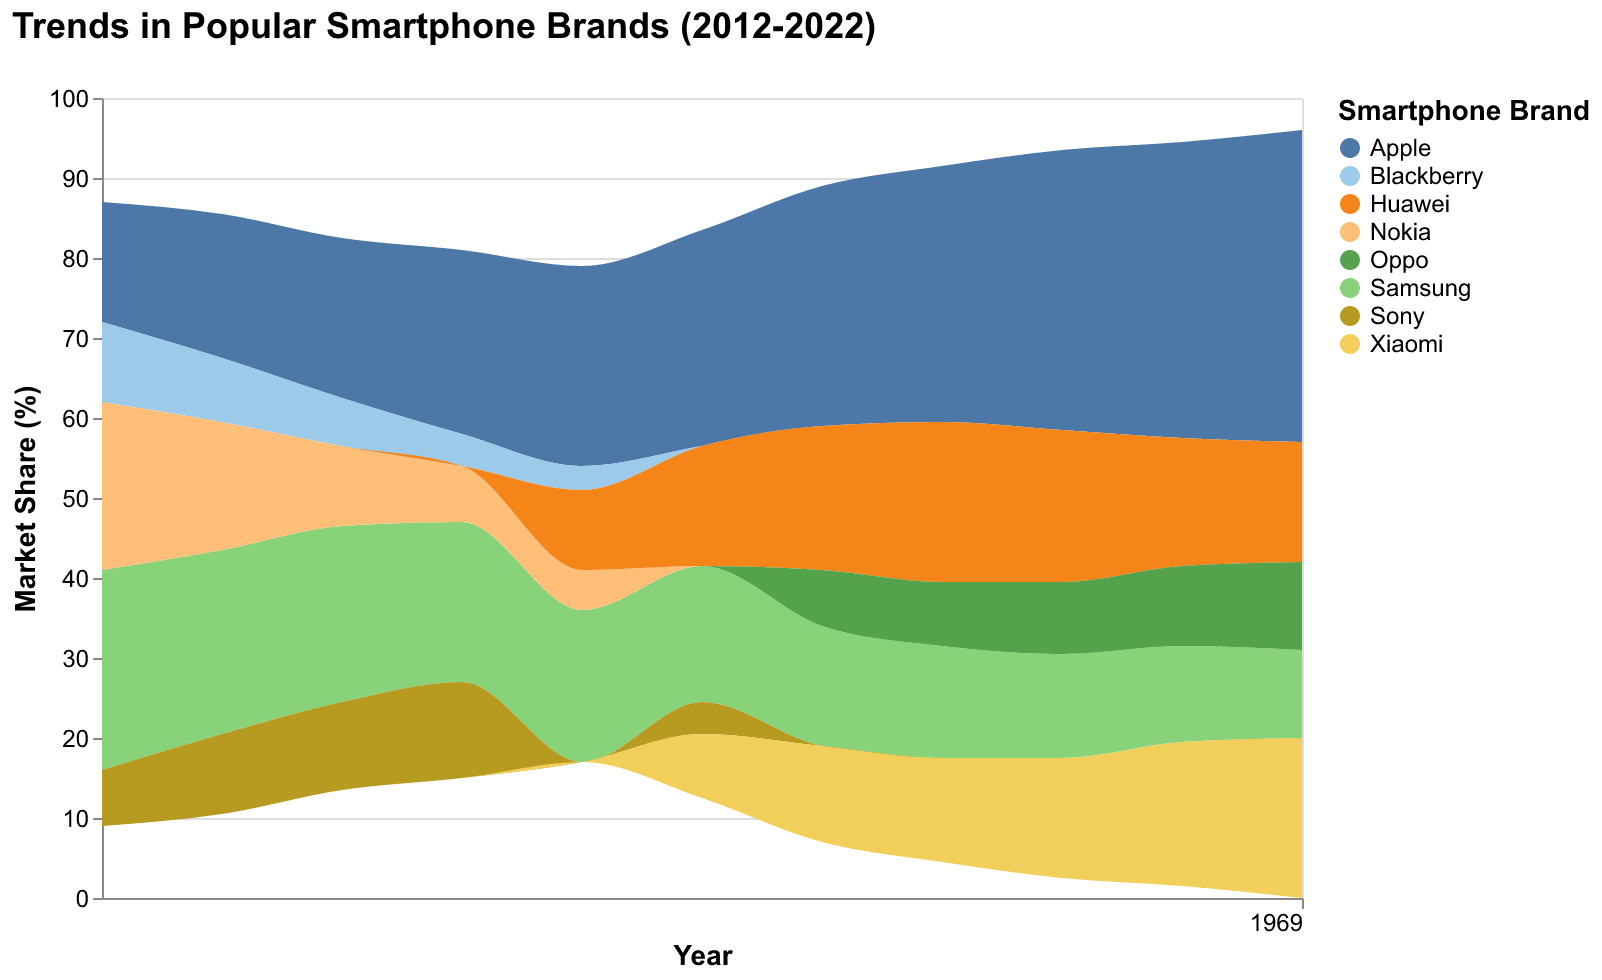What is the title of the figure? The title is located at the top of the figure and is meant to give a quick understanding of what the data represents.
Answer: Trends in Popular Smartphone Brands (2012-2022) Which brand had the highest market share in 2012? The figure uses color coding to differentiate brands and displays the market share on the y-axis for each year on the x-axis. In 2012, the largest section is for Samsung.
Answer: Samsung How has Apple's market share changed from 2012 to 2022? To determine this, observe Apple's market share in 2012 and compare it to the share in 2022 by looking at the height of the corresponding sections. It started at 15% in 2012 and increased to 39% in 2022.
Answer: Increased In what year did Xiaomi first appear in the market share data? To find this, look at the legend to identify Xiaomi's color and then trace back through the years until you no longer see its color. Xiaomi first appears in 2017.
Answer: 2017 Which year did Huawei achieve its highest market share, and what was it? By tracking Huawei's color through the years and checking the y-axis, one can see that Huawei's highest market share was 20% in 2019.
Answer: 2019, 20% Compare the market share of Samsung in 2013 and 2022. Check Samsung's market share by following its color from 2013 and 2022 and read the percentage off the y-axis. In 2013 it was 23%, and in 2022 it reduced to 11%.
Answer: Decreased What is the overall trend for BlackBerry's market share over the years? Observe the corresponding colors for BlackBerry in each year to see that it has continued to decrease, disappearing after 2016.
Answer: Decreased Which brands saw an increase in market share from 2019 to 2020? Look at the colors for the brands in 2019 and 2020 and check which sections increased in height. Apple, Xiaomi, and Oppo saw an increase in market share.
Answer: Apple, Xiaomi, Oppo Which brand had a market share decrease in consecutive years from 2020 to 2022? Analyzing the trendlines for all brands, Huawei shows a consistent decrease from 2020 (19%) to 2021 (16%) and further to 2022 (15%).
Answer: Huawei How does the market share of Oppo in 2021 compare to Xiaomi? Check both brands' market share for the year 2021; Oppo had a 10% market share, while Xiaomi had 18%.
Answer: Xiaomi is higher 